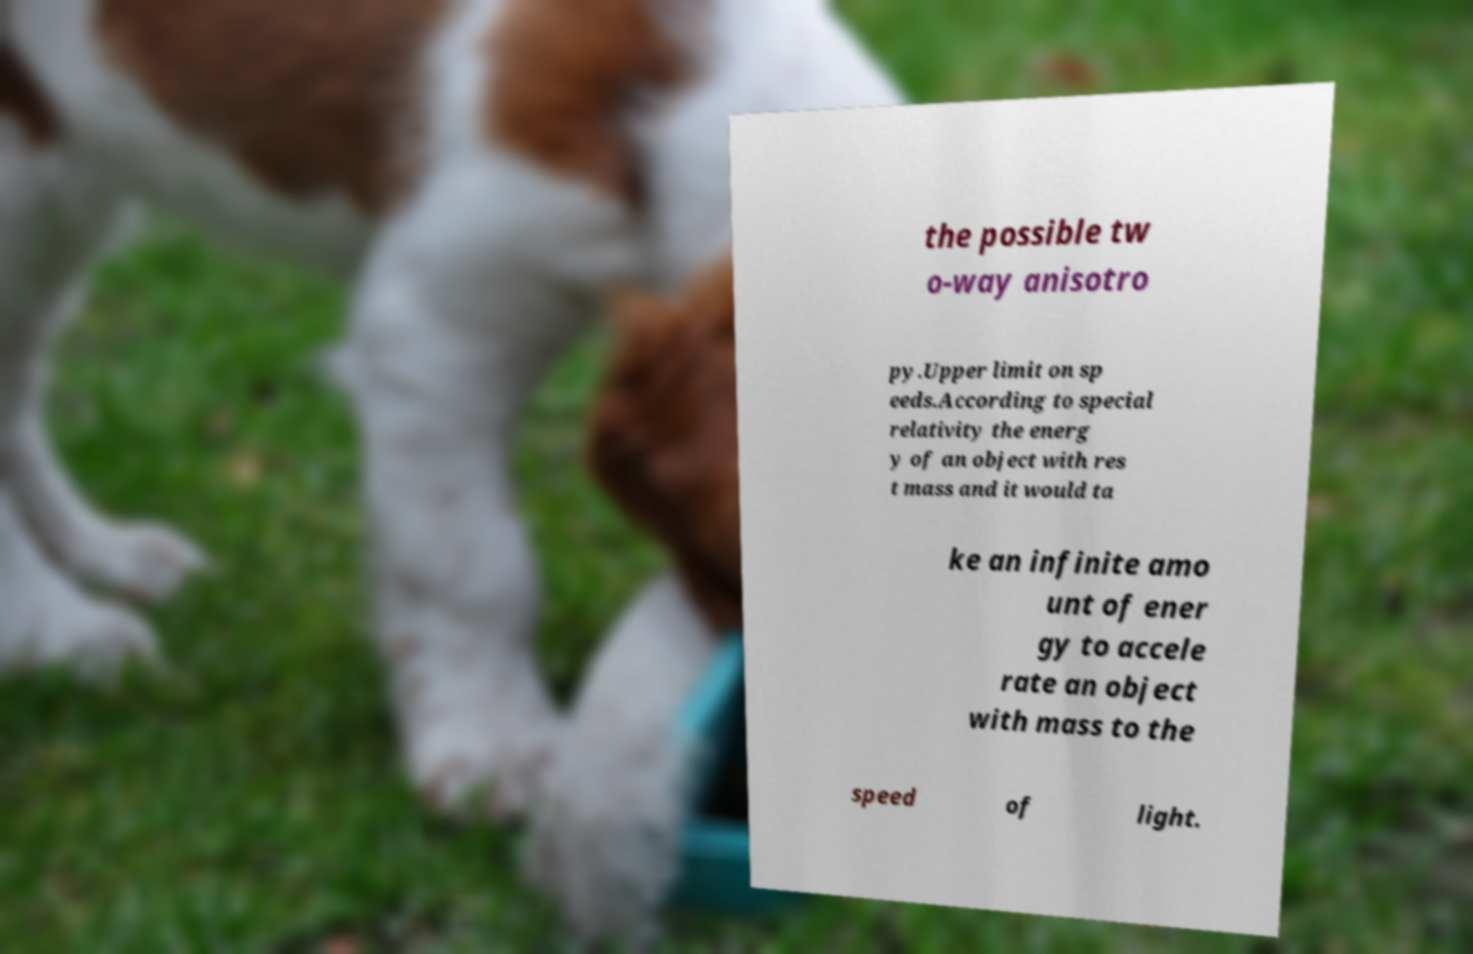Can you accurately transcribe the text from the provided image for me? the possible tw o-way anisotro py.Upper limit on sp eeds.According to special relativity the energ y of an object with res t mass and it would ta ke an infinite amo unt of ener gy to accele rate an object with mass to the speed of light. 